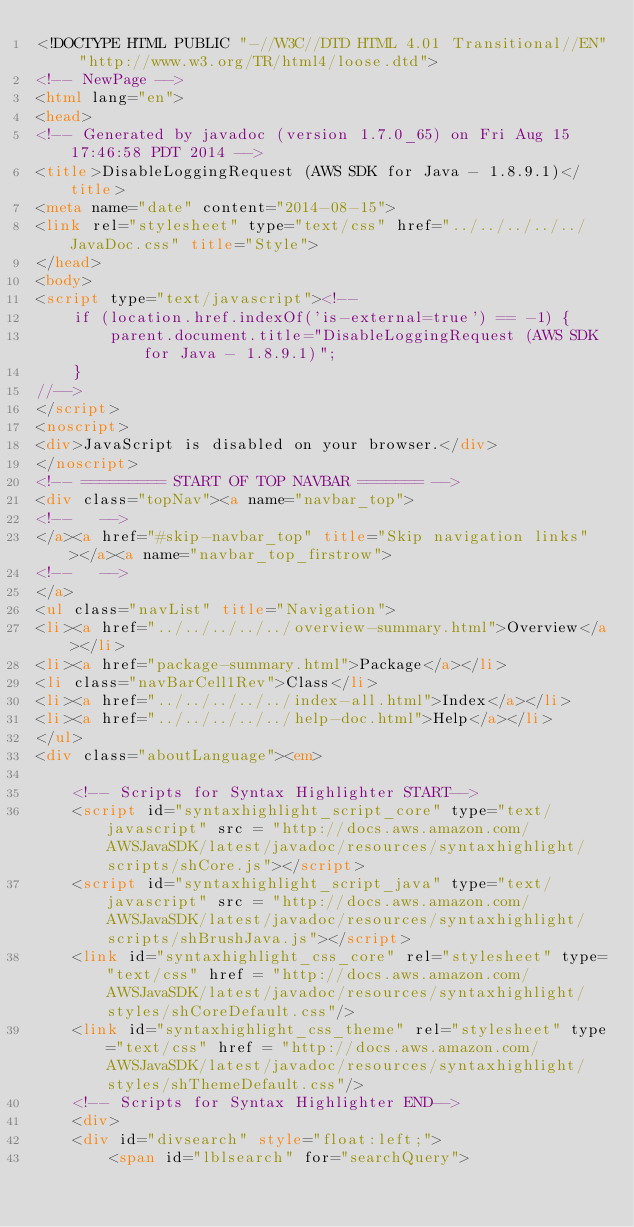<code> <loc_0><loc_0><loc_500><loc_500><_HTML_><!DOCTYPE HTML PUBLIC "-//W3C//DTD HTML 4.01 Transitional//EN" "http://www.w3.org/TR/html4/loose.dtd">
<!-- NewPage -->
<html lang="en">
<head>
<!-- Generated by javadoc (version 1.7.0_65) on Fri Aug 15 17:46:58 PDT 2014 -->
<title>DisableLoggingRequest (AWS SDK for Java - 1.8.9.1)</title>
<meta name="date" content="2014-08-15">
<link rel="stylesheet" type="text/css" href="../../../../../JavaDoc.css" title="Style">
</head>
<body>
<script type="text/javascript"><!--
    if (location.href.indexOf('is-external=true') == -1) {
        parent.document.title="DisableLoggingRequest (AWS SDK for Java - 1.8.9.1)";
    }
//-->
</script>
<noscript>
<div>JavaScript is disabled on your browser.</div>
</noscript>
<!-- ========= START OF TOP NAVBAR ======= -->
<div class="topNav"><a name="navbar_top">
<!--   -->
</a><a href="#skip-navbar_top" title="Skip navigation links"></a><a name="navbar_top_firstrow">
<!--   -->
</a>
<ul class="navList" title="Navigation">
<li><a href="../../../../../overview-summary.html">Overview</a></li>
<li><a href="package-summary.html">Package</a></li>
<li class="navBarCell1Rev">Class</li>
<li><a href="../../../../../index-all.html">Index</a></li>
<li><a href="../../../../../help-doc.html">Help</a></li>
</ul>
<div class="aboutLanguage"><em>

    <!-- Scripts for Syntax Highlighter START-->
    <script id="syntaxhighlight_script_core" type="text/javascript" src = "http://docs.aws.amazon.com/AWSJavaSDK/latest/javadoc/resources/syntaxhighlight/scripts/shCore.js"></script>
    <script id="syntaxhighlight_script_java" type="text/javascript" src = "http://docs.aws.amazon.com/AWSJavaSDK/latest/javadoc/resources/syntaxhighlight/scripts/shBrushJava.js"></script>
    <link id="syntaxhighlight_css_core" rel="stylesheet" type="text/css" href = "http://docs.aws.amazon.com/AWSJavaSDK/latest/javadoc/resources/syntaxhighlight/styles/shCoreDefault.css"/>
    <link id="syntaxhighlight_css_theme" rel="stylesheet" type="text/css" href = "http://docs.aws.amazon.com/AWSJavaSDK/latest/javadoc/resources/syntaxhighlight/styles/shThemeDefault.css"/>
    <!-- Scripts for Syntax Highlighter END-->
    <div>
    <div id="divsearch" style="float:left;">
        <span id="lblsearch" for="searchQuery"></code> 